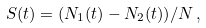Convert formula to latex. <formula><loc_0><loc_0><loc_500><loc_500>S ( t ) = ( N _ { 1 } ( t ) - N _ { 2 } ( t ) ) / N \, ,</formula> 